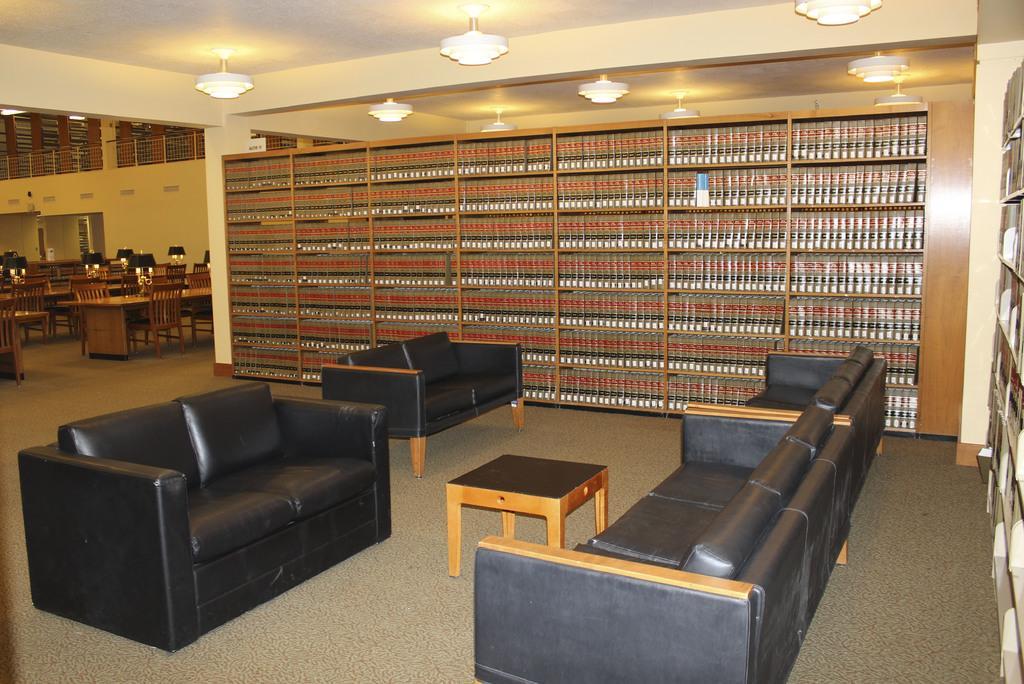Can you describe this image briefly? In this picture there are sofa and there are many books in the shelf. 